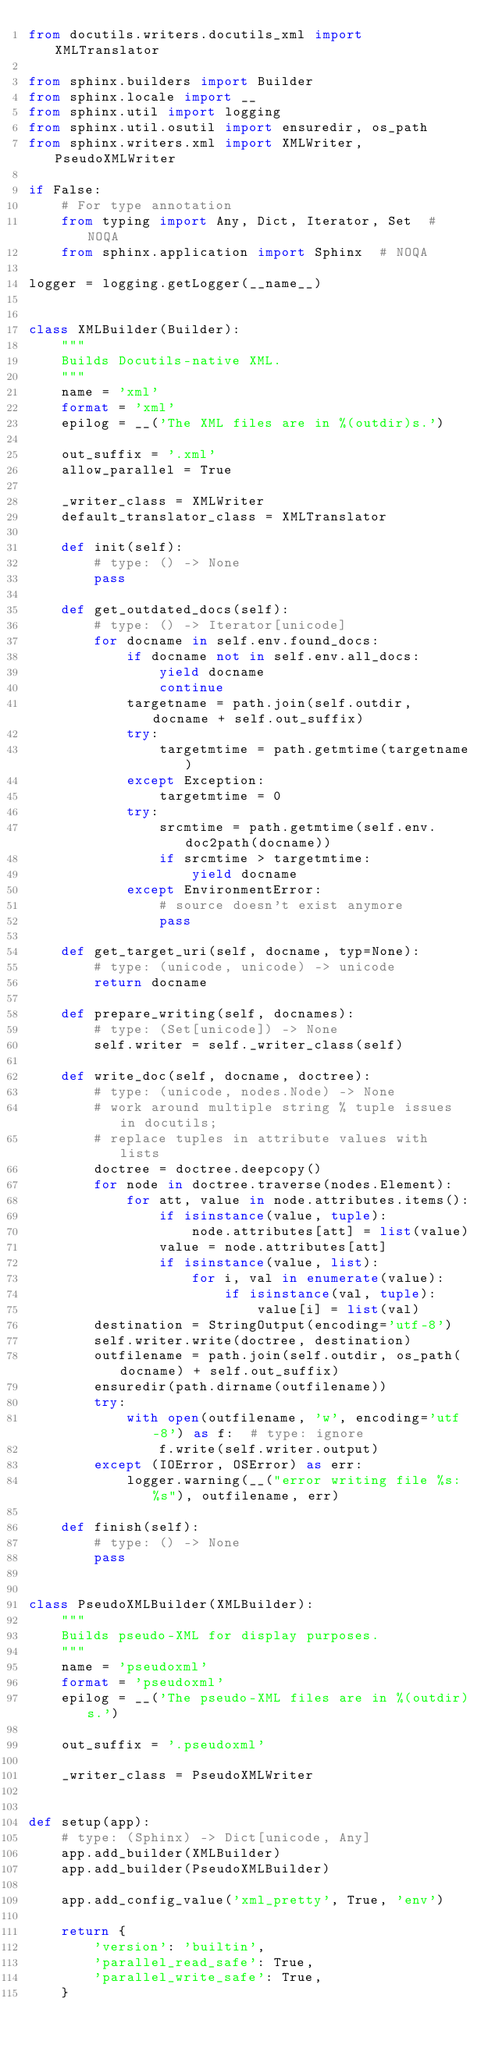<code> <loc_0><loc_0><loc_500><loc_500><_Python_>from docutils.writers.docutils_xml import XMLTranslator

from sphinx.builders import Builder
from sphinx.locale import __
from sphinx.util import logging
from sphinx.util.osutil import ensuredir, os_path
from sphinx.writers.xml import XMLWriter, PseudoXMLWriter

if False:
    # For type annotation
    from typing import Any, Dict, Iterator, Set  # NOQA
    from sphinx.application import Sphinx  # NOQA

logger = logging.getLogger(__name__)


class XMLBuilder(Builder):
    """
    Builds Docutils-native XML.
    """
    name = 'xml'
    format = 'xml'
    epilog = __('The XML files are in %(outdir)s.')

    out_suffix = '.xml'
    allow_parallel = True

    _writer_class = XMLWriter
    default_translator_class = XMLTranslator

    def init(self):
        # type: () -> None
        pass

    def get_outdated_docs(self):
        # type: () -> Iterator[unicode]
        for docname in self.env.found_docs:
            if docname not in self.env.all_docs:
                yield docname
                continue
            targetname = path.join(self.outdir, docname + self.out_suffix)
            try:
                targetmtime = path.getmtime(targetname)
            except Exception:
                targetmtime = 0
            try:
                srcmtime = path.getmtime(self.env.doc2path(docname))
                if srcmtime > targetmtime:
                    yield docname
            except EnvironmentError:
                # source doesn't exist anymore
                pass

    def get_target_uri(self, docname, typ=None):
        # type: (unicode, unicode) -> unicode
        return docname

    def prepare_writing(self, docnames):
        # type: (Set[unicode]) -> None
        self.writer = self._writer_class(self)

    def write_doc(self, docname, doctree):
        # type: (unicode, nodes.Node) -> None
        # work around multiple string % tuple issues in docutils;
        # replace tuples in attribute values with lists
        doctree = doctree.deepcopy()
        for node in doctree.traverse(nodes.Element):
            for att, value in node.attributes.items():
                if isinstance(value, tuple):
                    node.attributes[att] = list(value)
                value = node.attributes[att]
                if isinstance(value, list):
                    for i, val in enumerate(value):
                        if isinstance(val, tuple):
                            value[i] = list(val)
        destination = StringOutput(encoding='utf-8')
        self.writer.write(doctree, destination)
        outfilename = path.join(self.outdir, os_path(docname) + self.out_suffix)
        ensuredir(path.dirname(outfilename))
        try:
            with open(outfilename, 'w', encoding='utf-8') as f:  # type: ignore
                f.write(self.writer.output)
        except (IOError, OSError) as err:
            logger.warning(__("error writing file %s: %s"), outfilename, err)

    def finish(self):
        # type: () -> None
        pass


class PseudoXMLBuilder(XMLBuilder):
    """
    Builds pseudo-XML for display purposes.
    """
    name = 'pseudoxml'
    format = 'pseudoxml'
    epilog = __('The pseudo-XML files are in %(outdir)s.')

    out_suffix = '.pseudoxml'

    _writer_class = PseudoXMLWriter


def setup(app):
    # type: (Sphinx) -> Dict[unicode, Any]
    app.add_builder(XMLBuilder)
    app.add_builder(PseudoXMLBuilder)

    app.add_config_value('xml_pretty', True, 'env')

    return {
        'version': 'builtin',
        'parallel_read_safe': True,
        'parallel_write_safe': True,
    }
</code> 